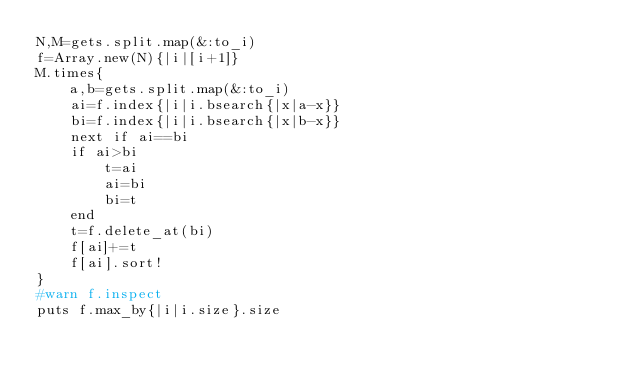<code> <loc_0><loc_0><loc_500><loc_500><_Ruby_>N,M=gets.split.map(&:to_i)
f=Array.new(N){|i|[i+1]}
M.times{
    a,b=gets.split.map(&:to_i)
    ai=f.index{|i|i.bsearch{|x|a-x}}
    bi=f.index{|i|i.bsearch{|x|b-x}}
    next if ai==bi
    if ai>bi
        t=ai
        ai=bi
        bi=t
    end
    t=f.delete_at(bi)
    f[ai]+=t
    f[ai].sort!
}
#warn f.inspect
puts f.max_by{|i|i.size}.size
</code> 